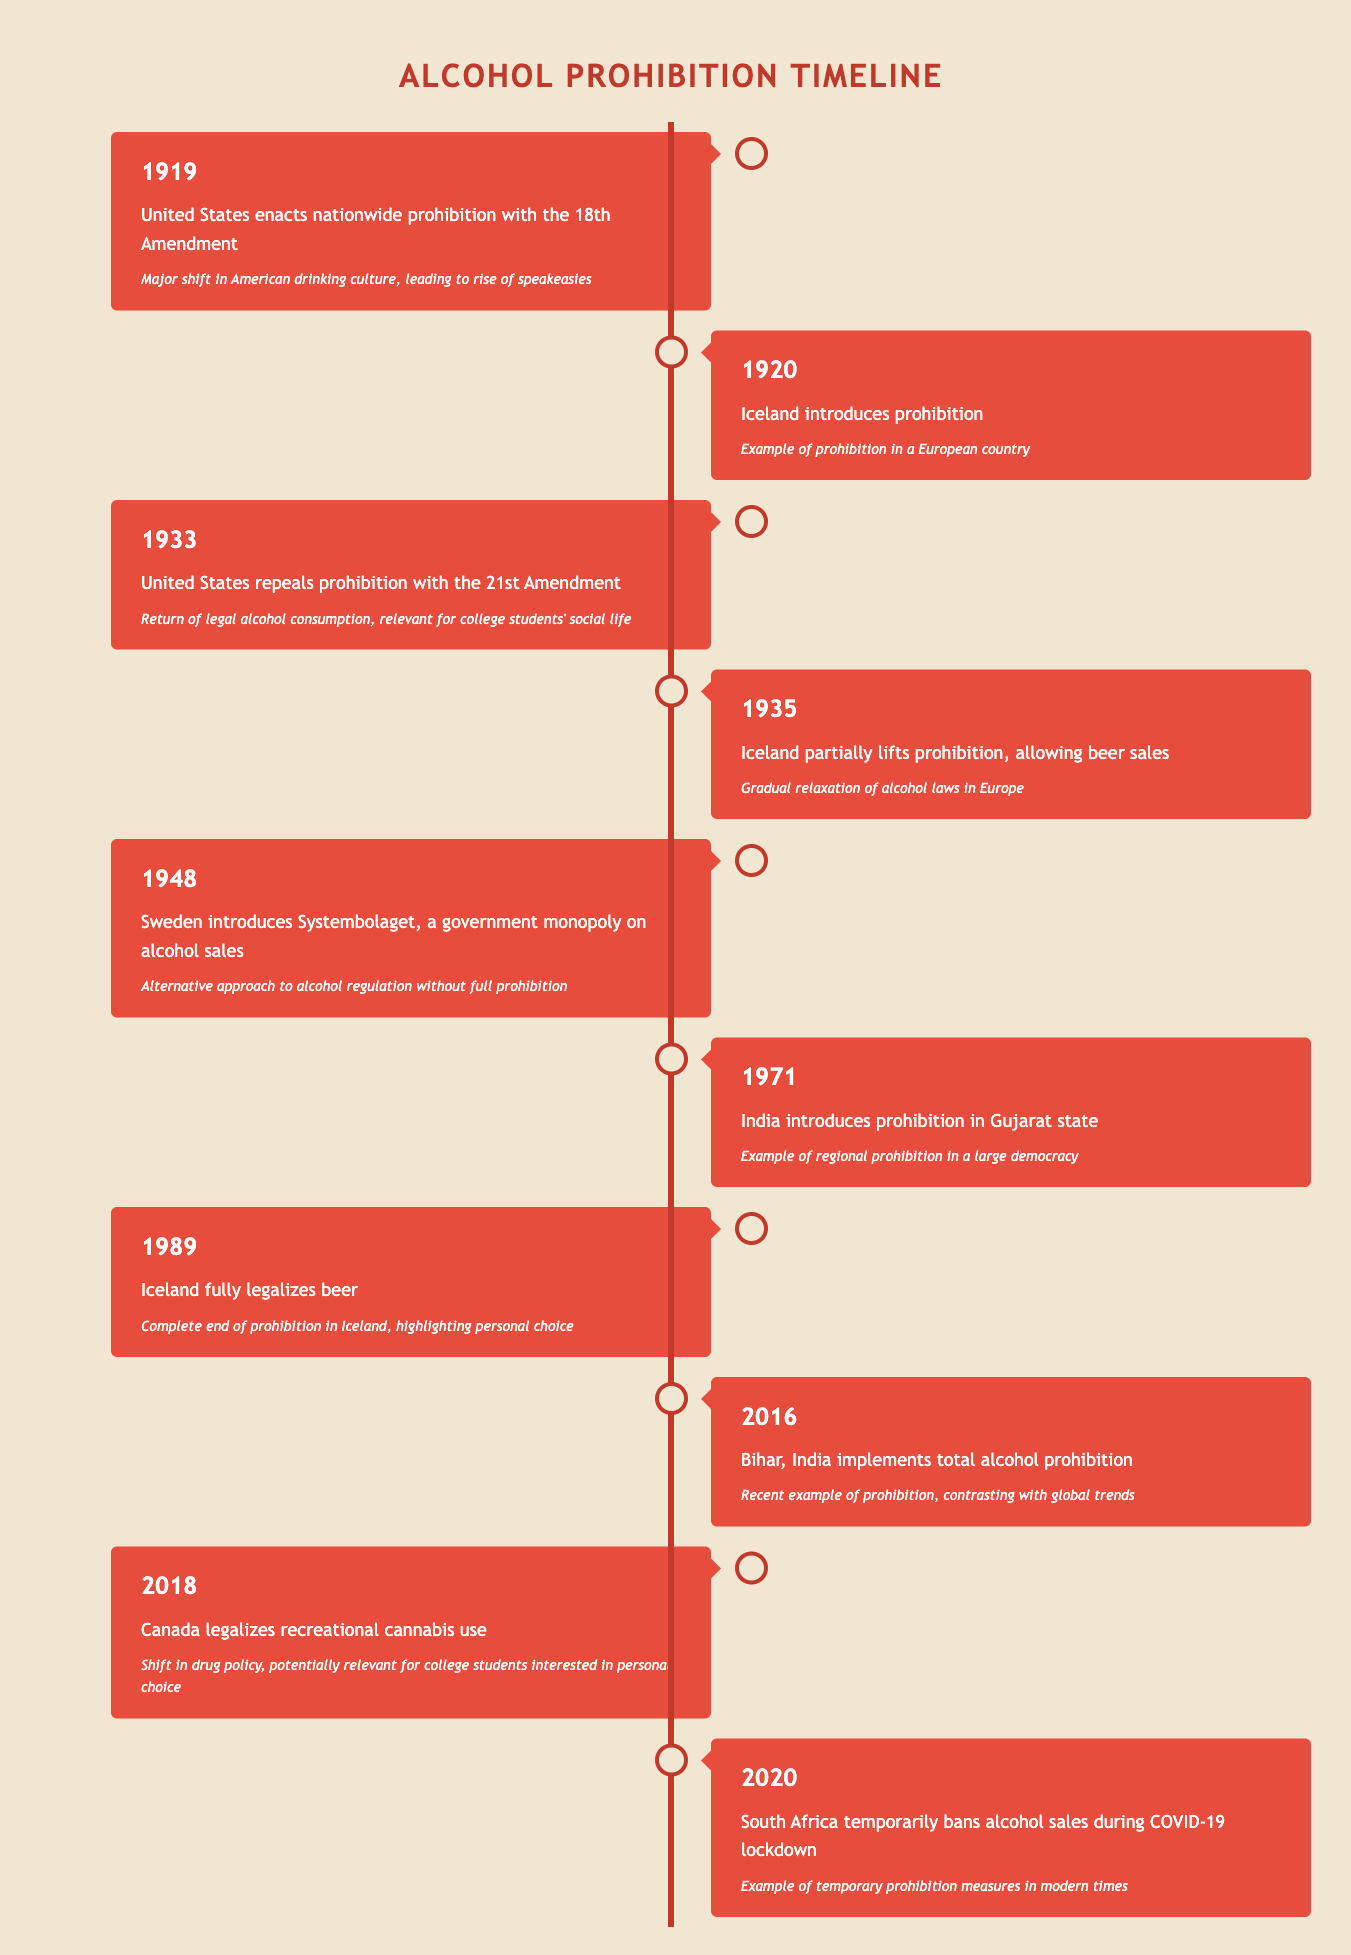What year did the United States repeal prohibition? The table indicates that the United States repealed prohibition with the 21st Amendment in the year 1933. This is clearly listed in the events from the timeline.
Answer: 1933 In what year did Iceland completely legalize beer? According to the timeline, Iceland fully legalized beer in 1989, signifying the end of its alcohol prohibition laws.
Answer: 1989 Was alcohol prohibition implemented in Sweden? The table does not show any indication that Sweden enacted alcohol prohibition; instead, it mentions that Sweden introduced Systembolaget, a government-controlled alcohol sales system in 1948. Hence, the answer is no.
Answer: No What is the significance of the 1933 event in the United States? The significance of the 1933 event, where the United States repealed prohibition, is highlighted in the table as it marks the return of legal alcohol consumption, which is vital for college students' social life.
Answer: Return of legal alcohol consumption Which two countries introduced alcohol prohibition before 1940? From the timeline data, Iceland introduced prohibition in 1920, and the United States enacted nationwide prohibition in 1919, making these the two countries that had such laws before 1940.
Answer: United States and Iceland How many years apart were the introduction of prohibition in Iceland and its repeal? The introduction of prohibition in Iceland was in 1920, and it was fully lifted in 1989. The difference in years is calculated as 1989 - 1920 = 69 years.
Answer: 69 years Which event shows a modern temporary prohibition of alcohol and when did it occur? The table indicates that South Africa temporarily banned alcohol sales during the COVID-19 lockdown in 2020. This is the event that reflects modern prohibition measures.
Answer: 2020 Is it true that the introduction and the repeal of prohibition in the United States happened in consecutive decades? Yes, the prohibition was enacted in 1919 (20s decade) and repealed in 1933 (30s decade). These two events indeed occur in consecutive decades based on the information provided.
Answer: Yes What was the trend in Iceland regarding beer sales from 1920 to 1989? The trend shows a gradual relaxation of prohibition laws; Iceland first introduced alcohol prohibition in 1920, partially lifted it in 1935 to allow beer sales, and fully legalized beer in 1989, indicating a shift from prohibition to acceptance over nearly 70 years.
Answer: Gradual relaxation of laws 